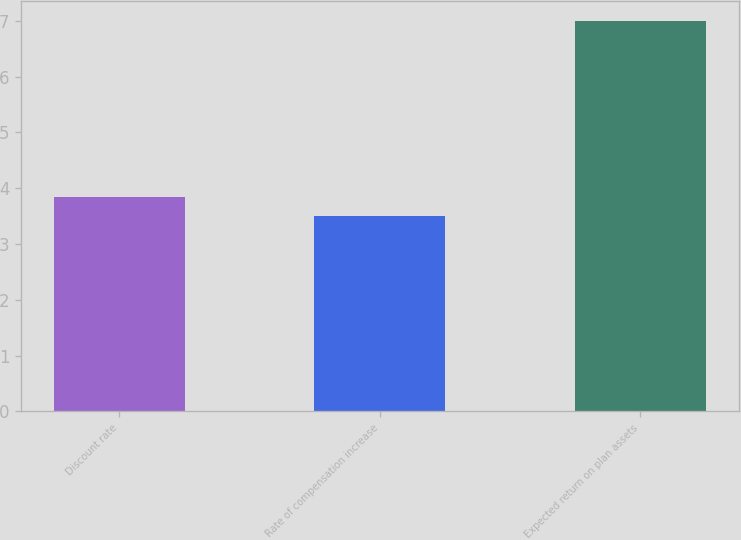Convert chart. <chart><loc_0><loc_0><loc_500><loc_500><bar_chart><fcel>Discount rate<fcel>Rate of compensation increase<fcel>Expected return on plan assets<nl><fcel>3.85<fcel>3.5<fcel>7<nl></chart> 